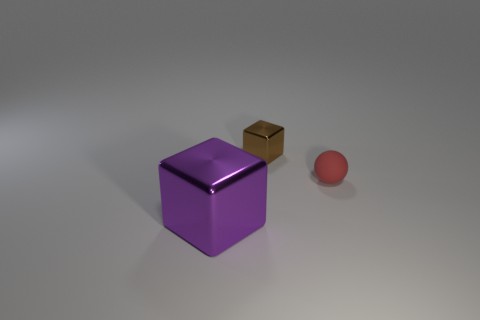How would you describe the lighting and shadows in the image? The image features soft lighting with diffuse shadows that hint at a light source located above and slightly to the right of the scene. This setup provides the objects with a gentle highlight along their edges while maintaining a soft transition between light and shadow, contributing to a three-dimensional appearance. 